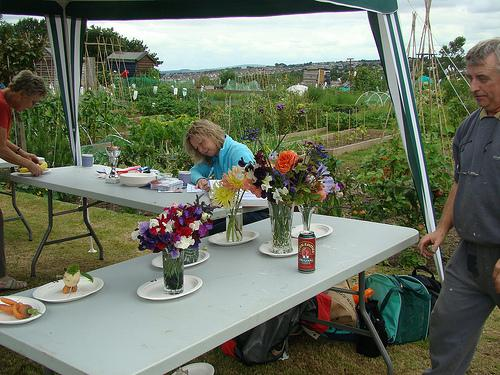Question: where was this picture taken?
Choices:
A. Picnic.
B. In the woods.
C. In the school.
D. In the garage.
Answer with the letter. Answer: A Question: how many people are visible?
Choices:
A. 4.
B. 5.
C. 3.
D. 6.
Answer with the letter. Answer: C Question: what are in the vases?
Choices:
A. Ashes.
B. Flowers.
C. Plants.
D. Bugs.
Answer with the letter. Answer: B Question: how many plates are on the front table?
Choices:
A. 1.
B. 2.
C. 7.
D. 3.
Answer with the letter. Answer: C Question: how many table legs are visible?
Choices:
A. 3.
B. 1.
C. 2.
D. 4.
Answer with the letter. Answer: A 